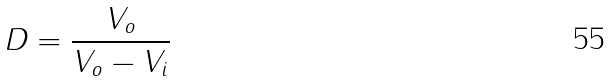Convert formula to latex. <formula><loc_0><loc_0><loc_500><loc_500>D = \frac { V _ { o } } { V _ { o } - V _ { i } }</formula> 